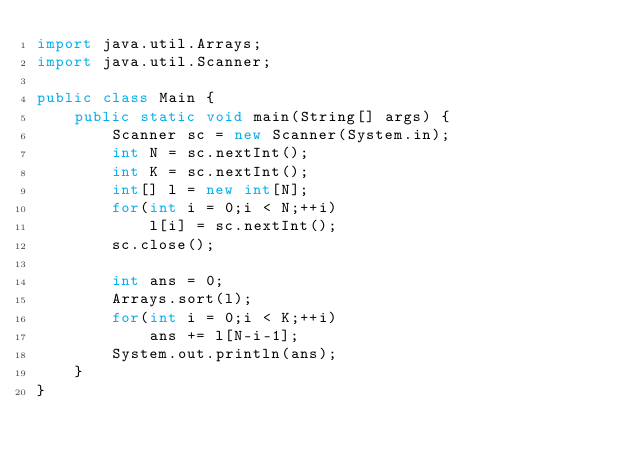Convert code to text. <code><loc_0><loc_0><loc_500><loc_500><_Java_>import java.util.Arrays;
import java.util.Scanner;

public class Main {
	public static void main(String[] args) {
		Scanner sc = new Scanner(System.in);
		int N = sc.nextInt();
		int K = sc.nextInt();
		int[] l = new int[N];
		for(int i = 0;i < N;++i)
			l[i] = sc.nextInt();
		sc.close();
		
		int ans = 0;
		Arrays.sort(l);
		for(int i = 0;i < K;++i)
			ans += l[N-i-1];
		System.out.println(ans);
	}
}
</code> 